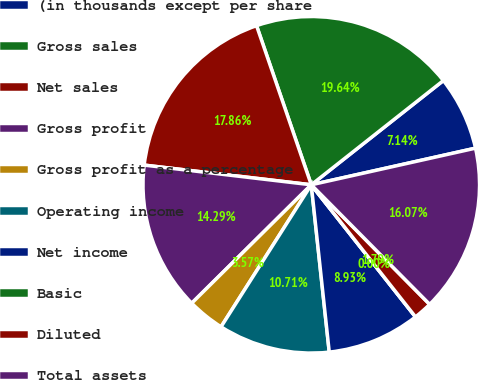Convert chart to OTSL. <chart><loc_0><loc_0><loc_500><loc_500><pie_chart><fcel>(in thousands except per share<fcel>Gross sales<fcel>Net sales<fcel>Gross profit<fcel>Gross profit as a percentage<fcel>Operating income<fcel>Net income<fcel>Basic<fcel>Diluted<fcel>Total assets<nl><fcel>7.14%<fcel>19.64%<fcel>17.86%<fcel>14.29%<fcel>3.57%<fcel>10.71%<fcel>8.93%<fcel>0.0%<fcel>1.79%<fcel>16.07%<nl></chart> 